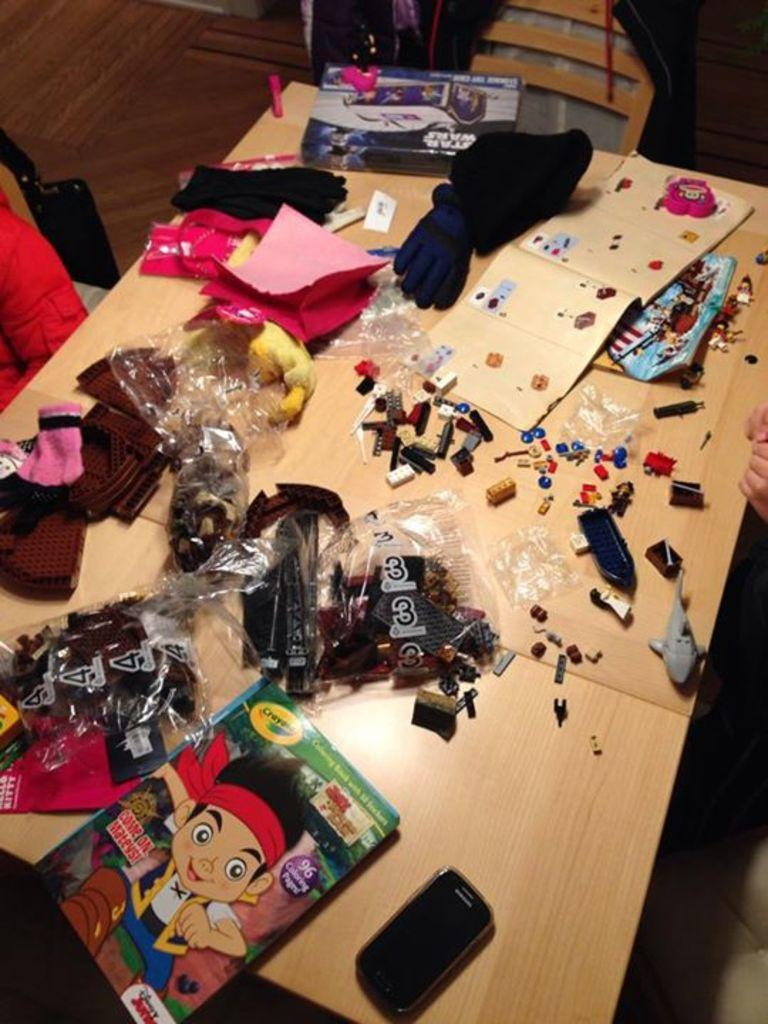What type of furniture is present in the image? There is a table in the image. What is on the table in the image? There are items on the table. Can you describe any part of a person visible in the image? A hand of a person is visible in the image. What type of bead is being used to prepare the meal in the image? There is no bead or meal preparation visible in the image. How does the society depicted in the image interact with each other? The image does not depict a society or any interactions between individuals. 